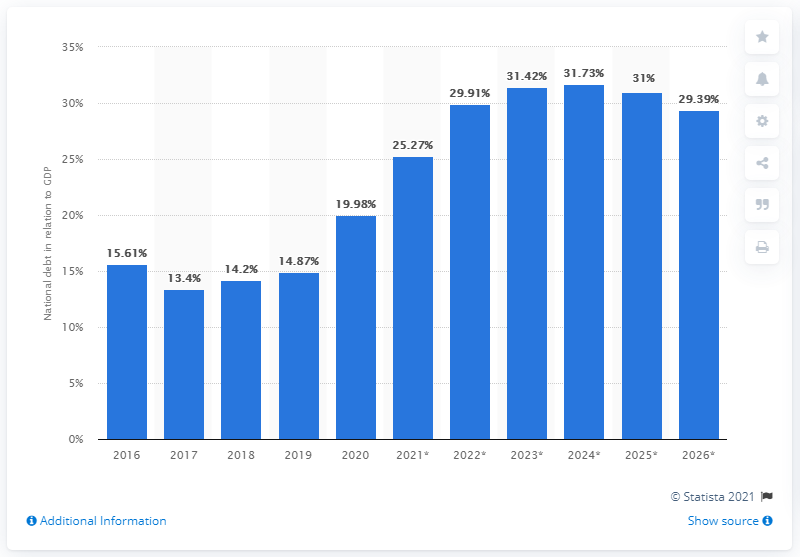Outline some significant characteristics in this image. The national debt of Botswana was declared to have ended in 2020. 